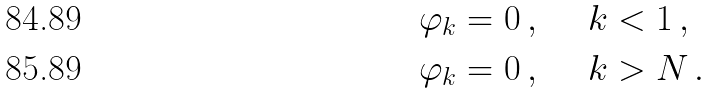Convert formula to latex. <formula><loc_0><loc_0><loc_500><loc_500>\varphi _ { k } = 0 \, , \quad \ k & < 1 \, , \\ \varphi _ { k } = 0 \, , \quad \ k & > N \, .</formula> 